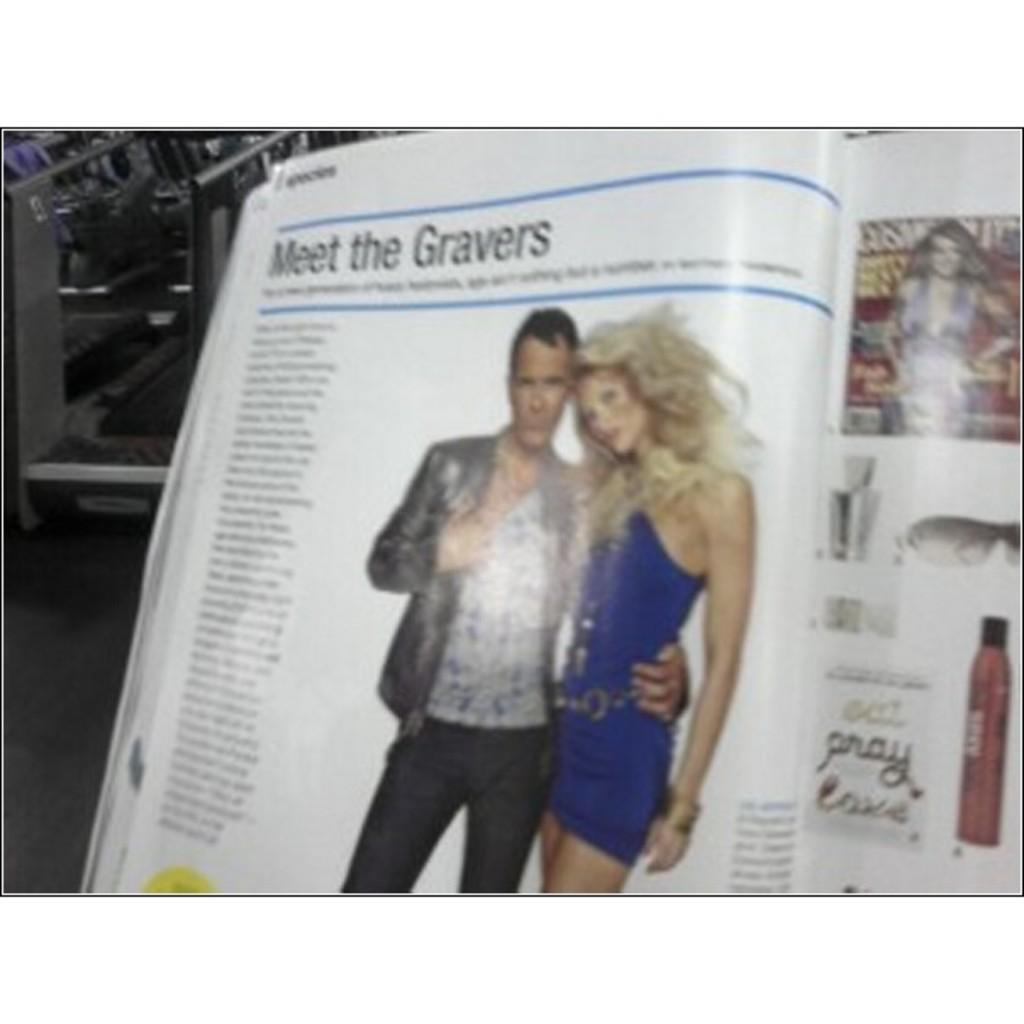What type of publication is in the image? There is a fashion magazine in the image. Who is standing beside the magazine? A man and a woman are standing beside the magazine. Can you describe the text on the left side of the image? Unfortunately, the provided facts do not mention any details about the text on the left side of the image. What type of suit is the man wearing in the image? The provided facts do not mention any details about the man's clothing, so we cannot determine if he is wearing a suit or any other type of clothing. What type of drink is the woman holding in the image? There is no mention of a drink or any other object being held by the woman in the provided facts. 